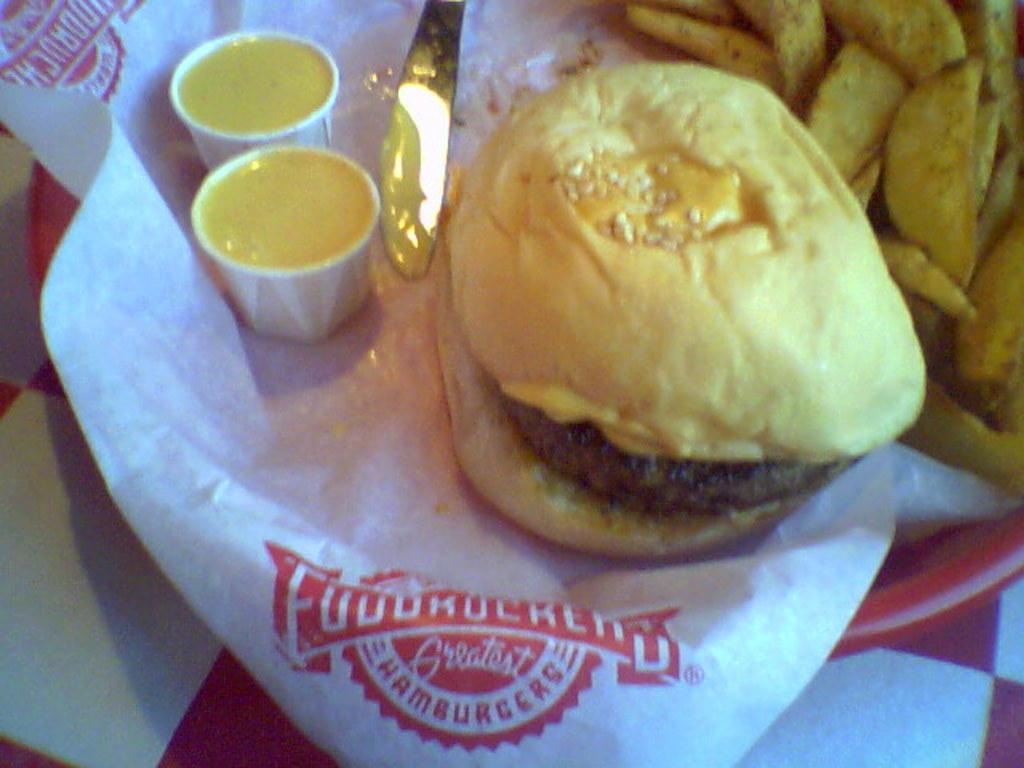What type of food is the main subject of the image? There is a burger in the image. What side dish is present with the burger? There are french fries in the image. What condiments are available for the burger and fries? There are two cups of sauce in the image. What utensil is present in the image? There is a knife in the image. What material is used for the paper in the image? The paper in the image is not specified, but it could be napkins or wrapping paper. Where are the food items placed? The items are on a plate, which is placed on an object. What type of boundary can be seen in the image? There is no boundary present in the image; it features a plate of food with various items. Is the plate of food sinking into quicksand in the image? No, the plate of food is not sinking into quicksand; it is placed on an object, likely a table or countertop. 